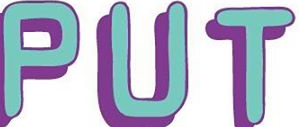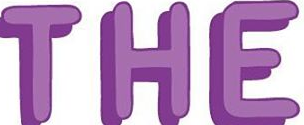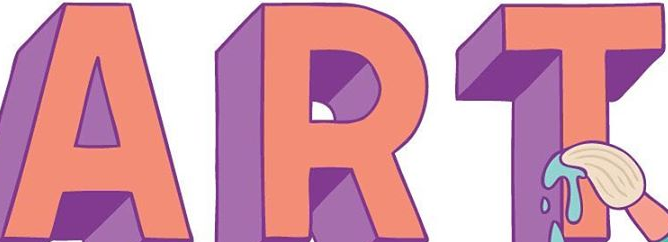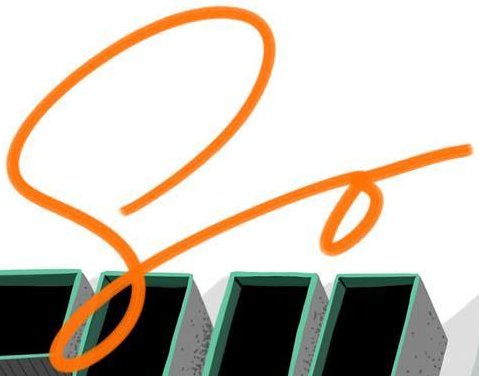Transcribe the words shown in these images in order, separated by a semicolon. PUT; THE; ART; So 